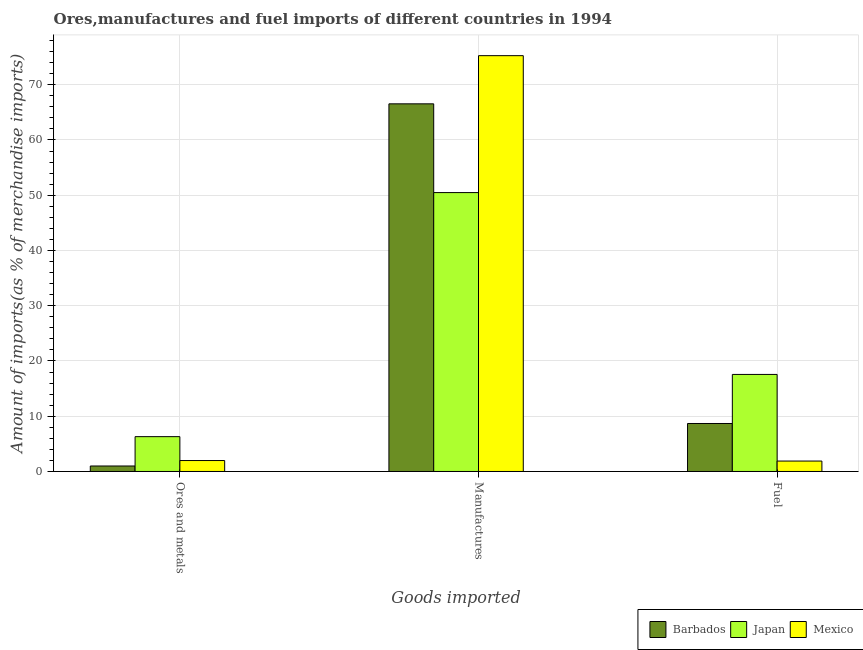How many groups of bars are there?
Make the answer very short. 3. How many bars are there on the 2nd tick from the left?
Offer a terse response. 3. How many bars are there on the 3rd tick from the right?
Provide a succinct answer. 3. What is the label of the 1st group of bars from the left?
Ensure brevity in your answer.  Ores and metals. What is the percentage of ores and metals imports in Mexico?
Your answer should be compact. 1.98. Across all countries, what is the maximum percentage of ores and metals imports?
Ensure brevity in your answer.  6.3. Across all countries, what is the minimum percentage of fuel imports?
Make the answer very short. 1.89. What is the total percentage of ores and metals imports in the graph?
Give a very brief answer. 9.28. What is the difference between the percentage of fuel imports in Mexico and that in Japan?
Your answer should be very brief. -15.68. What is the difference between the percentage of fuel imports in Barbados and the percentage of ores and metals imports in Mexico?
Offer a very short reply. 6.7. What is the average percentage of manufactures imports per country?
Keep it short and to the point. 64.1. What is the difference between the percentage of fuel imports and percentage of ores and metals imports in Mexico?
Your answer should be compact. -0.09. What is the ratio of the percentage of fuel imports in Mexico to that in Barbados?
Your response must be concise. 0.22. What is the difference between the highest and the second highest percentage of fuel imports?
Your answer should be compact. 8.88. What is the difference between the highest and the lowest percentage of ores and metals imports?
Your response must be concise. 5.31. In how many countries, is the percentage of manufactures imports greater than the average percentage of manufactures imports taken over all countries?
Make the answer very short. 2. Is the sum of the percentage of manufactures imports in Mexico and Japan greater than the maximum percentage of ores and metals imports across all countries?
Your response must be concise. Yes. What does the 1st bar from the left in Fuel represents?
Provide a succinct answer. Barbados. Is it the case that in every country, the sum of the percentage of ores and metals imports and percentage of manufactures imports is greater than the percentage of fuel imports?
Offer a terse response. Yes. How many bars are there?
Your answer should be compact. 9. What is the difference between two consecutive major ticks on the Y-axis?
Ensure brevity in your answer.  10. Are the values on the major ticks of Y-axis written in scientific E-notation?
Your response must be concise. No. Does the graph contain grids?
Make the answer very short. Yes. Where does the legend appear in the graph?
Provide a succinct answer. Bottom right. How many legend labels are there?
Provide a succinct answer. 3. What is the title of the graph?
Give a very brief answer. Ores,manufactures and fuel imports of different countries in 1994. Does "Mauritius" appear as one of the legend labels in the graph?
Your response must be concise. No. What is the label or title of the X-axis?
Give a very brief answer. Goods imported. What is the label or title of the Y-axis?
Keep it short and to the point. Amount of imports(as % of merchandise imports). What is the Amount of imports(as % of merchandise imports) in Barbados in Ores and metals?
Keep it short and to the point. 0.99. What is the Amount of imports(as % of merchandise imports) in Japan in Ores and metals?
Provide a succinct answer. 6.3. What is the Amount of imports(as % of merchandise imports) of Mexico in Ores and metals?
Provide a succinct answer. 1.98. What is the Amount of imports(as % of merchandise imports) in Barbados in Manufactures?
Keep it short and to the point. 66.55. What is the Amount of imports(as % of merchandise imports) of Japan in Manufactures?
Your response must be concise. 50.48. What is the Amount of imports(as % of merchandise imports) of Mexico in Manufactures?
Offer a very short reply. 75.26. What is the Amount of imports(as % of merchandise imports) in Barbados in Fuel?
Provide a succinct answer. 8.69. What is the Amount of imports(as % of merchandise imports) in Japan in Fuel?
Your answer should be very brief. 17.57. What is the Amount of imports(as % of merchandise imports) of Mexico in Fuel?
Provide a short and direct response. 1.89. Across all Goods imported, what is the maximum Amount of imports(as % of merchandise imports) of Barbados?
Offer a very short reply. 66.55. Across all Goods imported, what is the maximum Amount of imports(as % of merchandise imports) in Japan?
Offer a terse response. 50.48. Across all Goods imported, what is the maximum Amount of imports(as % of merchandise imports) in Mexico?
Ensure brevity in your answer.  75.26. Across all Goods imported, what is the minimum Amount of imports(as % of merchandise imports) of Barbados?
Give a very brief answer. 0.99. Across all Goods imported, what is the minimum Amount of imports(as % of merchandise imports) of Japan?
Offer a very short reply. 6.3. Across all Goods imported, what is the minimum Amount of imports(as % of merchandise imports) of Mexico?
Offer a terse response. 1.89. What is the total Amount of imports(as % of merchandise imports) of Barbados in the graph?
Give a very brief answer. 76.23. What is the total Amount of imports(as % of merchandise imports) of Japan in the graph?
Make the answer very short. 74.35. What is the total Amount of imports(as % of merchandise imports) of Mexico in the graph?
Give a very brief answer. 79.14. What is the difference between the Amount of imports(as % of merchandise imports) of Barbados in Ores and metals and that in Manufactures?
Ensure brevity in your answer.  -65.55. What is the difference between the Amount of imports(as % of merchandise imports) in Japan in Ores and metals and that in Manufactures?
Your answer should be very brief. -44.18. What is the difference between the Amount of imports(as % of merchandise imports) in Mexico in Ores and metals and that in Manufactures?
Keep it short and to the point. -73.28. What is the difference between the Amount of imports(as % of merchandise imports) in Barbados in Ores and metals and that in Fuel?
Ensure brevity in your answer.  -7.69. What is the difference between the Amount of imports(as % of merchandise imports) in Japan in Ores and metals and that in Fuel?
Make the answer very short. -11.26. What is the difference between the Amount of imports(as % of merchandise imports) in Mexico in Ores and metals and that in Fuel?
Give a very brief answer. 0.09. What is the difference between the Amount of imports(as % of merchandise imports) of Barbados in Manufactures and that in Fuel?
Ensure brevity in your answer.  57.86. What is the difference between the Amount of imports(as % of merchandise imports) in Japan in Manufactures and that in Fuel?
Offer a very short reply. 32.92. What is the difference between the Amount of imports(as % of merchandise imports) of Mexico in Manufactures and that in Fuel?
Offer a very short reply. 73.38. What is the difference between the Amount of imports(as % of merchandise imports) in Barbados in Ores and metals and the Amount of imports(as % of merchandise imports) in Japan in Manufactures?
Make the answer very short. -49.49. What is the difference between the Amount of imports(as % of merchandise imports) of Barbados in Ores and metals and the Amount of imports(as % of merchandise imports) of Mexico in Manufactures?
Provide a short and direct response. -74.27. What is the difference between the Amount of imports(as % of merchandise imports) of Japan in Ores and metals and the Amount of imports(as % of merchandise imports) of Mexico in Manufactures?
Provide a short and direct response. -68.96. What is the difference between the Amount of imports(as % of merchandise imports) in Barbados in Ores and metals and the Amount of imports(as % of merchandise imports) in Japan in Fuel?
Your response must be concise. -16.57. What is the difference between the Amount of imports(as % of merchandise imports) of Barbados in Ores and metals and the Amount of imports(as % of merchandise imports) of Mexico in Fuel?
Make the answer very short. -0.89. What is the difference between the Amount of imports(as % of merchandise imports) in Japan in Ores and metals and the Amount of imports(as % of merchandise imports) in Mexico in Fuel?
Keep it short and to the point. 4.42. What is the difference between the Amount of imports(as % of merchandise imports) in Barbados in Manufactures and the Amount of imports(as % of merchandise imports) in Japan in Fuel?
Offer a terse response. 48.98. What is the difference between the Amount of imports(as % of merchandise imports) of Barbados in Manufactures and the Amount of imports(as % of merchandise imports) of Mexico in Fuel?
Provide a succinct answer. 64.66. What is the difference between the Amount of imports(as % of merchandise imports) of Japan in Manufactures and the Amount of imports(as % of merchandise imports) of Mexico in Fuel?
Give a very brief answer. 48.59. What is the average Amount of imports(as % of merchandise imports) in Barbados per Goods imported?
Provide a succinct answer. 25.41. What is the average Amount of imports(as % of merchandise imports) of Japan per Goods imported?
Ensure brevity in your answer.  24.78. What is the average Amount of imports(as % of merchandise imports) in Mexico per Goods imported?
Provide a short and direct response. 26.38. What is the difference between the Amount of imports(as % of merchandise imports) in Barbados and Amount of imports(as % of merchandise imports) in Japan in Ores and metals?
Ensure brevity in your answer.  -5.31. What is the difference between the Amount of imports(as % of merchandise imports) of Barbados and Amount of imports(as % of merchandise imports) of Mexico in Ores and metals?
Make the answer very short. -0.99. What is the difference between the Amount of imports(as % of merchandise imports) in Japan and Amount of imports(as % of merchandise imports) in Mexico in Ores and metals?
Provide a succinct answer. 4.32. What is the difference between the Amount of imports(as % of merchandise imports) of Barbados and Amount of imports(as % of merchandise imports) of Japan in Manufactures?
Make the answer very short. 16.06. What is the difference between the Amount of imports(as % of merchandise imports) of Barbados and Amount of imports(as % of merchandise imports) of Mexico in Manufactures?
Your answer should be very brief. -8.72. What is the difference between the Amount of imports(as % of merchandise imports) in Japan and Amount of imports(as % of merchandise imports) in Mexico in Manufactures?
Keep it short and to the point. -24.78. What is the difference between the Amount of imports(as % of merchandise imports) in Barbados and Amount of imports(as % of merchandise imports) in Japan in Fuel?
Ensure brevity in your answer.  -8.88. What is the difference between the Amount of imports(as % of merchandise imports) of Barbados and Amount of imports(as % of merchandise imports) of Mexico in Fuel?
Your answer should be compact. 6.8. What is the difference between the Amount of imports(as % of merchandise imports) in Japan and Amount of imports(as % of merchandise imports) in Mexico in Fuel?
Give a very brief answer. 15.68. What is the ratio of the Amount of imports(as % of merchandise imports) in Barbados in Ores and metals to that in Manufactures?
Your answer should be compact. 0.01. What is the ratio of the Amount of imports(as % of merchandise imports) in Japan in Ores and metals to that in Manufactures?
Offer a terse response. 0.12. What is the ratio of the Amount of imports(as % of merchandise imports) of Mexico in Ores and metals to that in Manufactures?
Your answer should be compact. 0.03. What is the ratio of the Amount of imports(as % of merchandise imports) in Barbados in Ores and metals to that in Fuel?
Provide a short and direct response. 0.11. What is the ratio of the Amount of imports(as % of merchandise imports) of Japan in Ores and metals to that in Fuel?
Your answer should be compact. 0.36. What is the ratio of the Amount of imports(as % of merchandise imports) in Mexico in Ores and metals to that in Fuel?
Your response must be concise. 1.05. What is the ratio of the Amount of imports(as % of merchandise imports) of Barbados in Manufactures to that in Fuel?
Your answer should be very brief. 7.66. What is the ratio of the Amount of imports(as % of merchandise imports) in Japan in Manufactures to that in Fuel?
Keep it short and to the point. 2.87. What is the ratio of the Amount of imports(as % of merchandise imports) in Mexico in Manufactures to that in Fuel?
Provide a short and direct response. 39.86. What is the difference between the highest and the second highest Amount of imports(as % of merchandise imports) in Barbados?
Make the answer very short. 57.86. What is the difference between the highest and the second highest Amount of imports(as % of merchandise imports) of Japan?
Make the answer very short. 32.92. What is the difference between the highest and the second highest Amount of imports(as % of merchandise imports) of Mexico?
Ensure brevity in your answer.  73.28. What is the difference between the highest and the lowest Amount of imports(as % of merchandise imports) in Barbados?
Provide a succinct answer. 65.55. What is the difference between the highest and the lowest Amount of imports(as % of merchandise imports) in Japan?
Keep it short and to the point. 44.18. What is the difference between the highest and the lowest Amount of imports(as % of merchandise imports) of Mexico?
Ensure brevity in your answer.  73.38. 